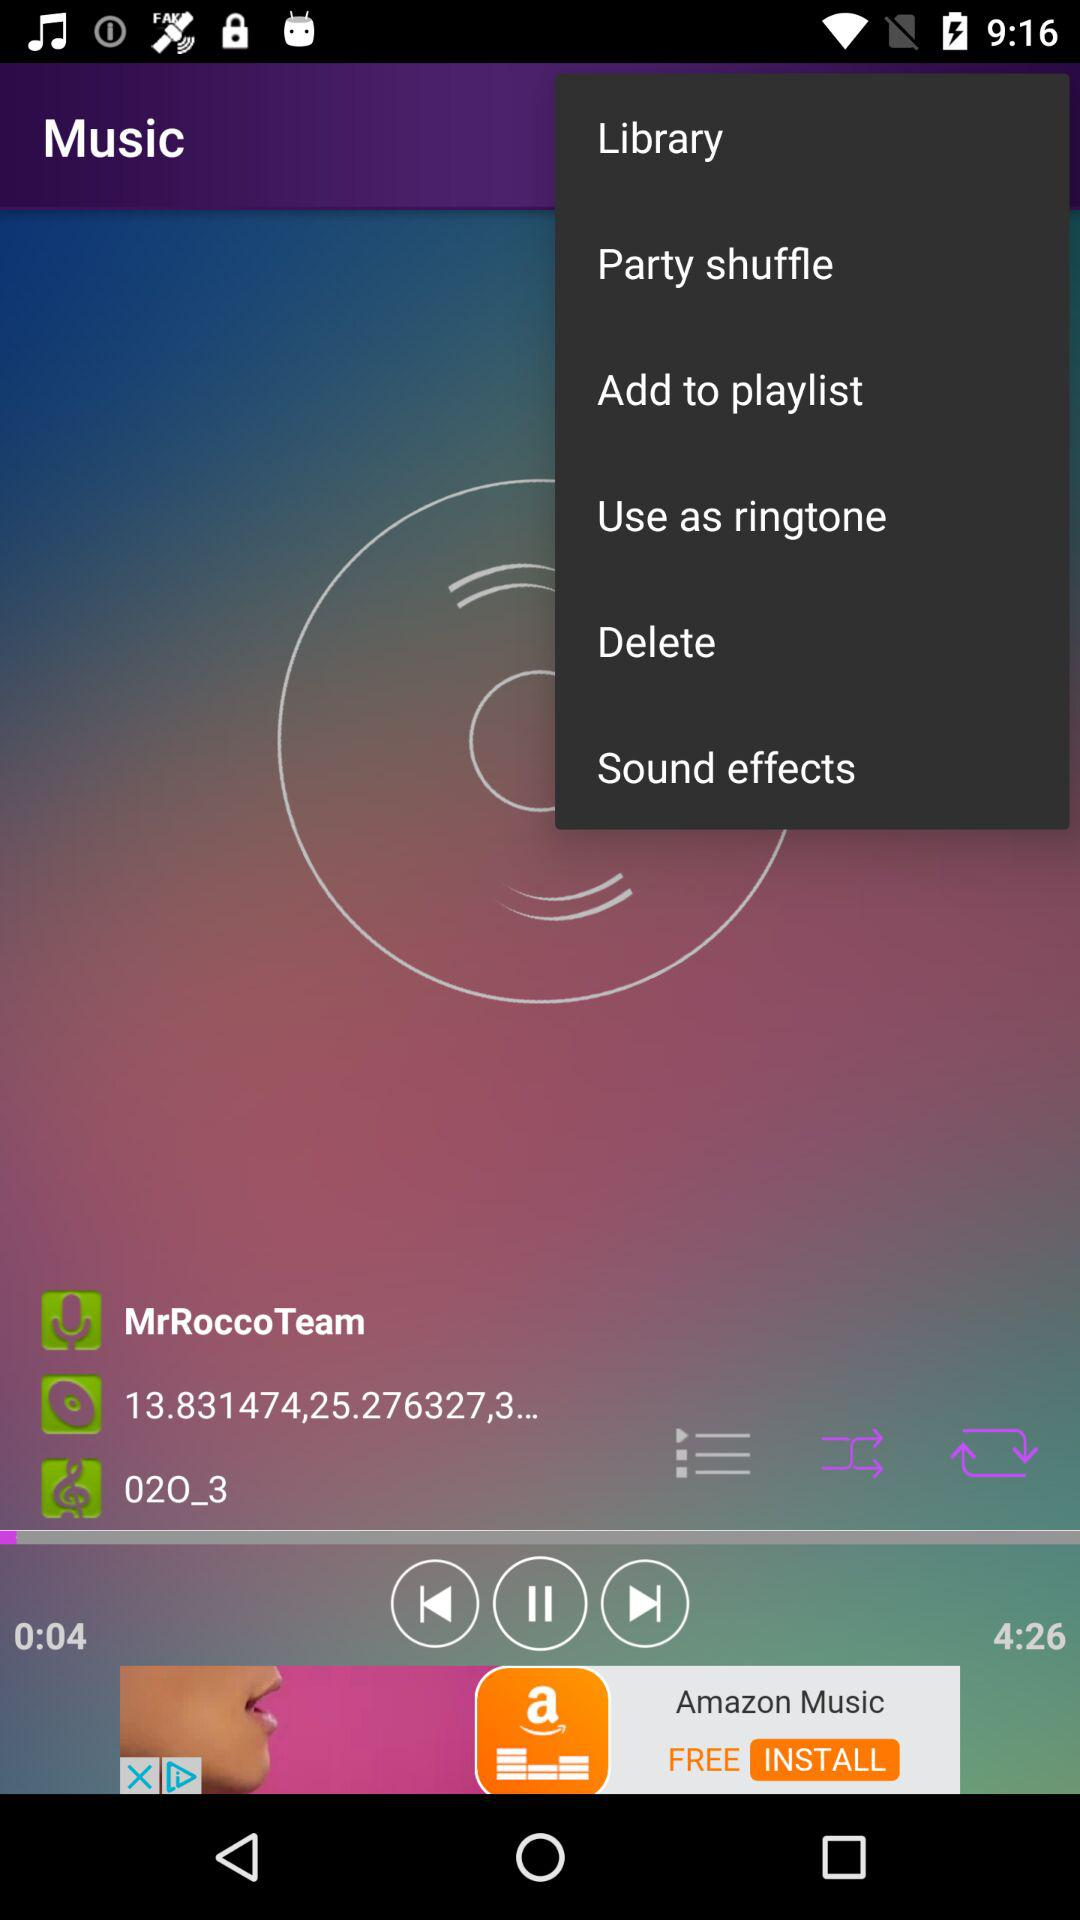What is the duration of the song? The duration of the song is 4:26. 